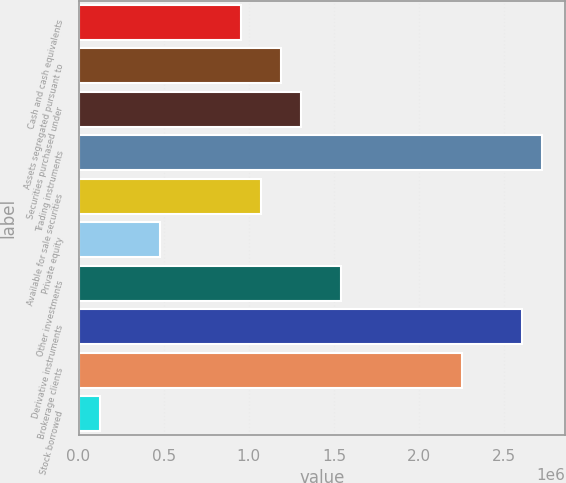Convert chart to OTSL. <chart><loc_0><loc_0><loc_500><loc_500><bar_chart><fcel>Cash and cash equivalents<fcel>Assets segregated pursuant to<fcel>Securities purchased under<fcel>Trading instruments<fcel>Available for sale securities<fcel>Private equity<fcel>Other investments<fcel>Derivative instruments<fcel>Brokerage clients<fcel>Stock borrowed<nl><fcel>952131<fcel>1.18809e+06<fcel>1.30606e+06<fcel>2.7218e+06<fcel>1.07011e+06<fcel>480219<fcel>1.54202e+06<fcel>2.60382e+06<fcel>2.24989e+06<fcel>126285<nl></chart> 